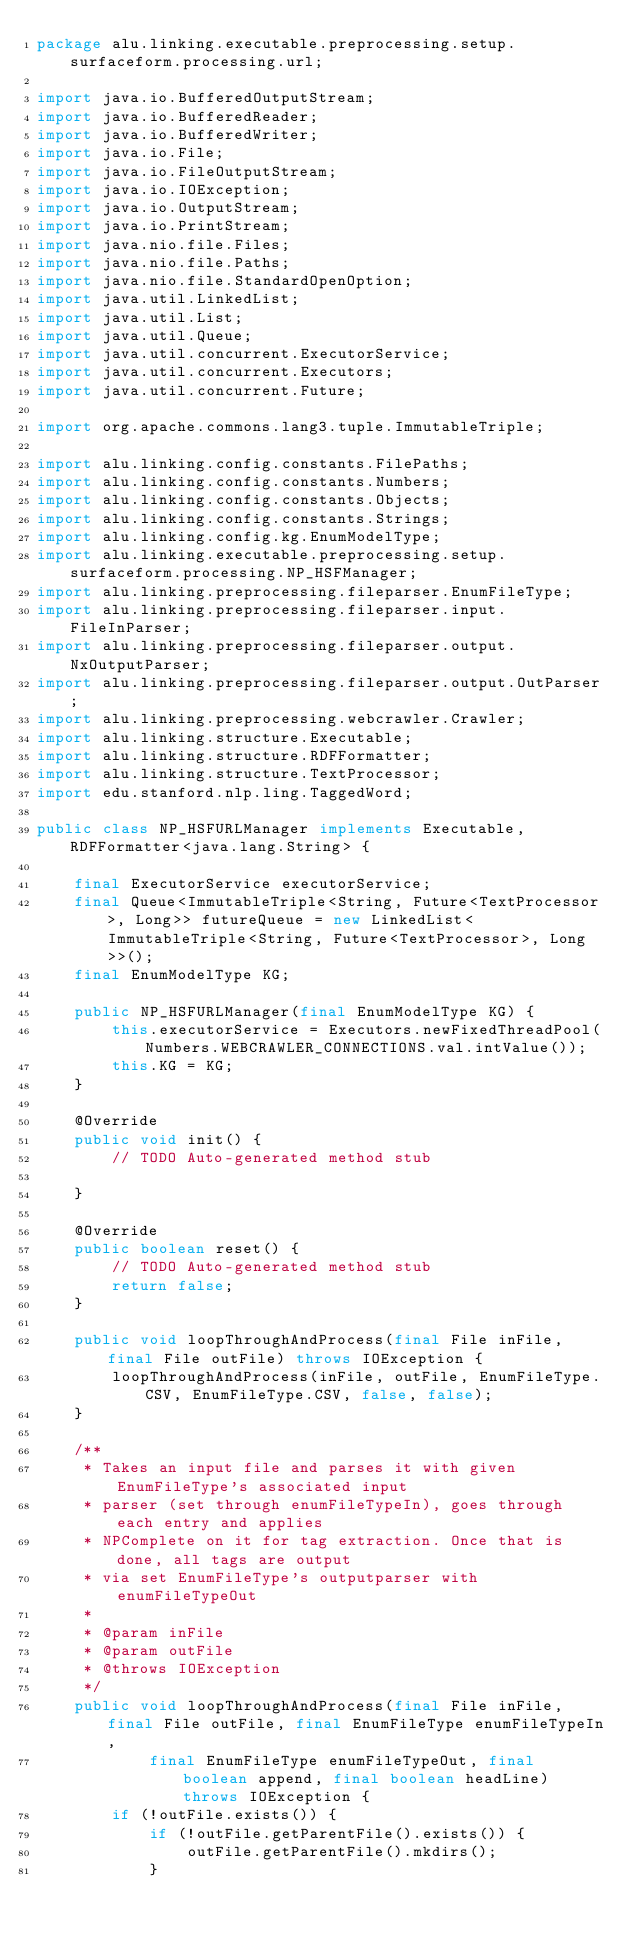<code> <loc_0><loc_0><loc_500><loc_500><_Java_>package alu.linking.executable.preprocessing.setup.surfaceform.processing.url;

import java.io.BufferedOutputStream;
import java.io.BufferedReader;
import java.io.BufferedWriter;
import java.io.File;
import java.io.FileOutputStream;
import java.io.IOException;
import java.io.OutputStream;
import java.io.PrintStream;
import java.nio.file.Files;
import java.nio.file.Paths;
import java.nio.file.StandardOpenOption;
import java.util.LinkedList;
import java.util.List;
import java.util.Queue;
import java.util.concurrent.ExecutorService;
import java.util.concurrent.Executors;
import java.util.concurrent.Future;

import org.apache.commons.lang3.tuple.ImmutableTriple;

import alu.linking.config.constants.FilePaths;
import alu.linking.config.constants.Numbers;
import alu.linking.config.constants.Objects;
import alu.linking.config.constants.Strings;
import alu.linking.config.kg.EnumModelType;
import alu.linking.executable.preprocessing.setup.surfaceform.processing.NP_HSFManager;
import alu.linking.preprocessing.fileparser.EnumFileType;
import alu.linking.preprocessing.fileparser.input.FileInParser;
import alu.linking.preprocessing.fileparser.output.NxOutputParser;
import alu.linking.preprocessing.fileparser.output.OutParser;
import alu.linking.preprocessing.webcrawler.Crawler;
import alu.linking.structure.Executable;
import alu.linking.structure.RDFFormatter;
import alu.linking.structure.TextProcessor;
import edu.stanford.nlp.ling.TaggedWord;

public class NP_HSFURLManager implements Executable, RDFFormatter<java.lang.String> {

	final ExecutorService executorService;
	final Queue<ImmutableTriple<String, Future<TextProcessor>, Long>> futureQueue = new LinkedList<ImmutableTriple<String, Future<TextProcessor>, Long>>();
	final EnumModelType KG;

	public NP_HSFURLManager(final EnumModelType KG) {
		this.executorService = Executors.newFixedThreadPool(Numbers.WEBCRAWLER_CONNECTIONS.val.intValue());
		this.KG = KG;
	}

	@Override
	public void init() {
		// TODO Auto-generated method stub

	}

	@Override
	public boolean reset() {
		// TODO Auto-generated method stub
		return false;
	}

	public void loopThroughAndProcess(final File inFile, final File outFile) throws IOException {
		loopThroughAndProcess(inFile, outFile, EnumFileType.CSV, EnumFileType.CSV, false, false);
	}

	/**
	 * Takes an input file and parses it with given EnumFileType's associated input
	 * parser (set through enumFileTypeIn), goes through each entry and applies
	 * NPComplete on it for tag extraction. Once that is done, all tags are output
	 * via set EnumFileType's outputparser with enumFileTypeOut
	 * 
	 * @param inFile
	 * @param outFile
	 * @throws IOException
	 */
	public void loopThroughAndProcess(final File inFile, final File outFile, final EnumFileType enumFileTypeIn,
			final EnumFileType enumFileTypeOut, final boolean append, final boolean headLine) throws IOException {
		if (!outFile.exists()) {
			if (!outFile.getParentFile().exists()) {
				outFile.getParentFile().mkdirs();
			}</code> 